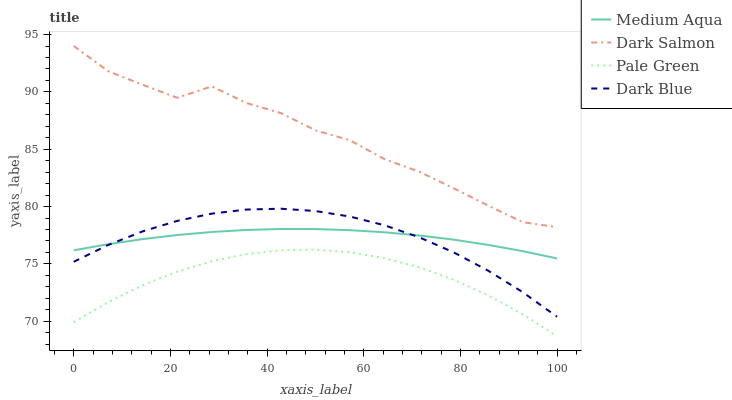Does Pale Green have the minimum area under the curve?
Answer yes or no. Yes. Does Dark Salmon have the maximum area under the curve?
Answer yes or no. Yes. Does Medium Aqua have the minimum area under the curve?
Answer yes or no. No. Does Medium Aqua have the maximum area under the curve?
Answer yes or no. No. Is Medium Aqua the smoothest?
Answer yes or no. Yes. Is Dark Salmon the roughest?
Answer yes or no. Yes. Is Pale Green the smoothest?
Answer yes or no. No. Is Pale Green the roughest?
Answer yes or no. No. Does Pale Green have the lowest value?
Answer yes or no. Yes. Does Medium Aqua have the lowest value?
Answer yes or no. No. Does Dark Salmon have the highest value?
Answer yes or no. Yes. Does Medium Aqua have the highest value?
Answer yes or no. No. Is Dark Blue less than Dark Salmon?
Answer yes or no. Yes. Is Dark Salmon greater than Medium Aqua?
Answer yes or no. Yes. Does Dark Blue intersect Medium Aqua?
Answer yes or no. Yes. Is Dark Blue less than Medium Aqua?
Answer yes or no. No. Is Dark Blue greater than Medium Aqua?
Answer yes or no. No. Does Dark Blue intersect Dark Salmon?
Answer yes or no. No. 